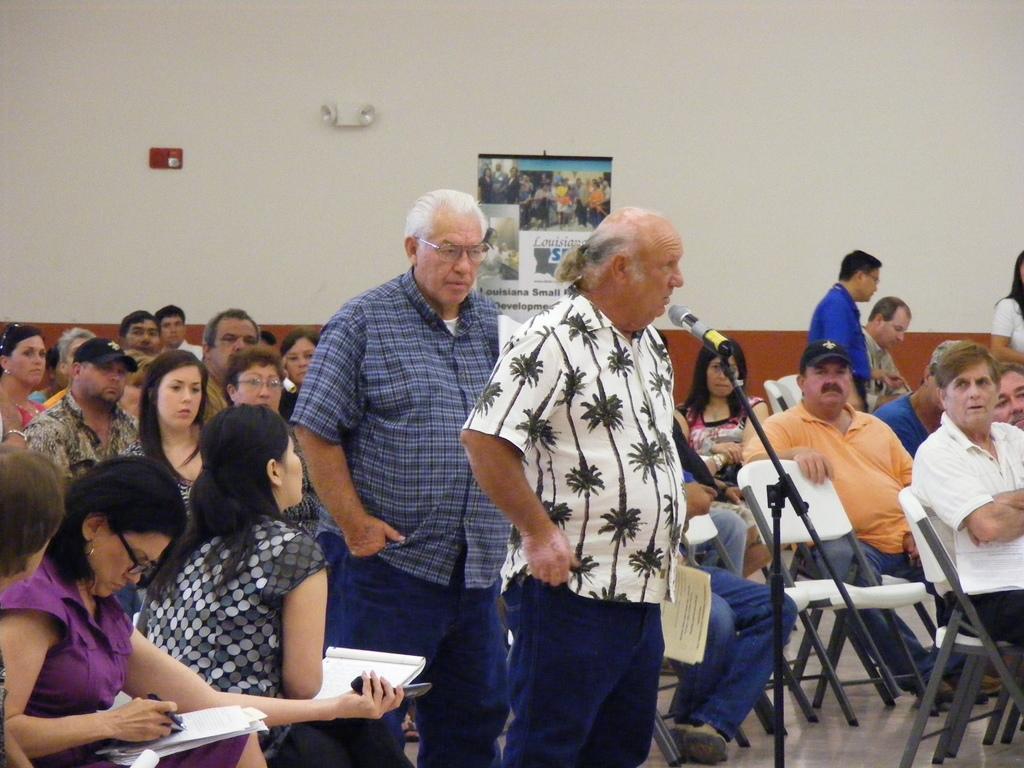Please provide a concise description of this image. Here we can see group of people sitting on the chairs and there are few persons standing on the floor. Here we can see a man standing in front of a mike. In the background we can see a poster and wall. 